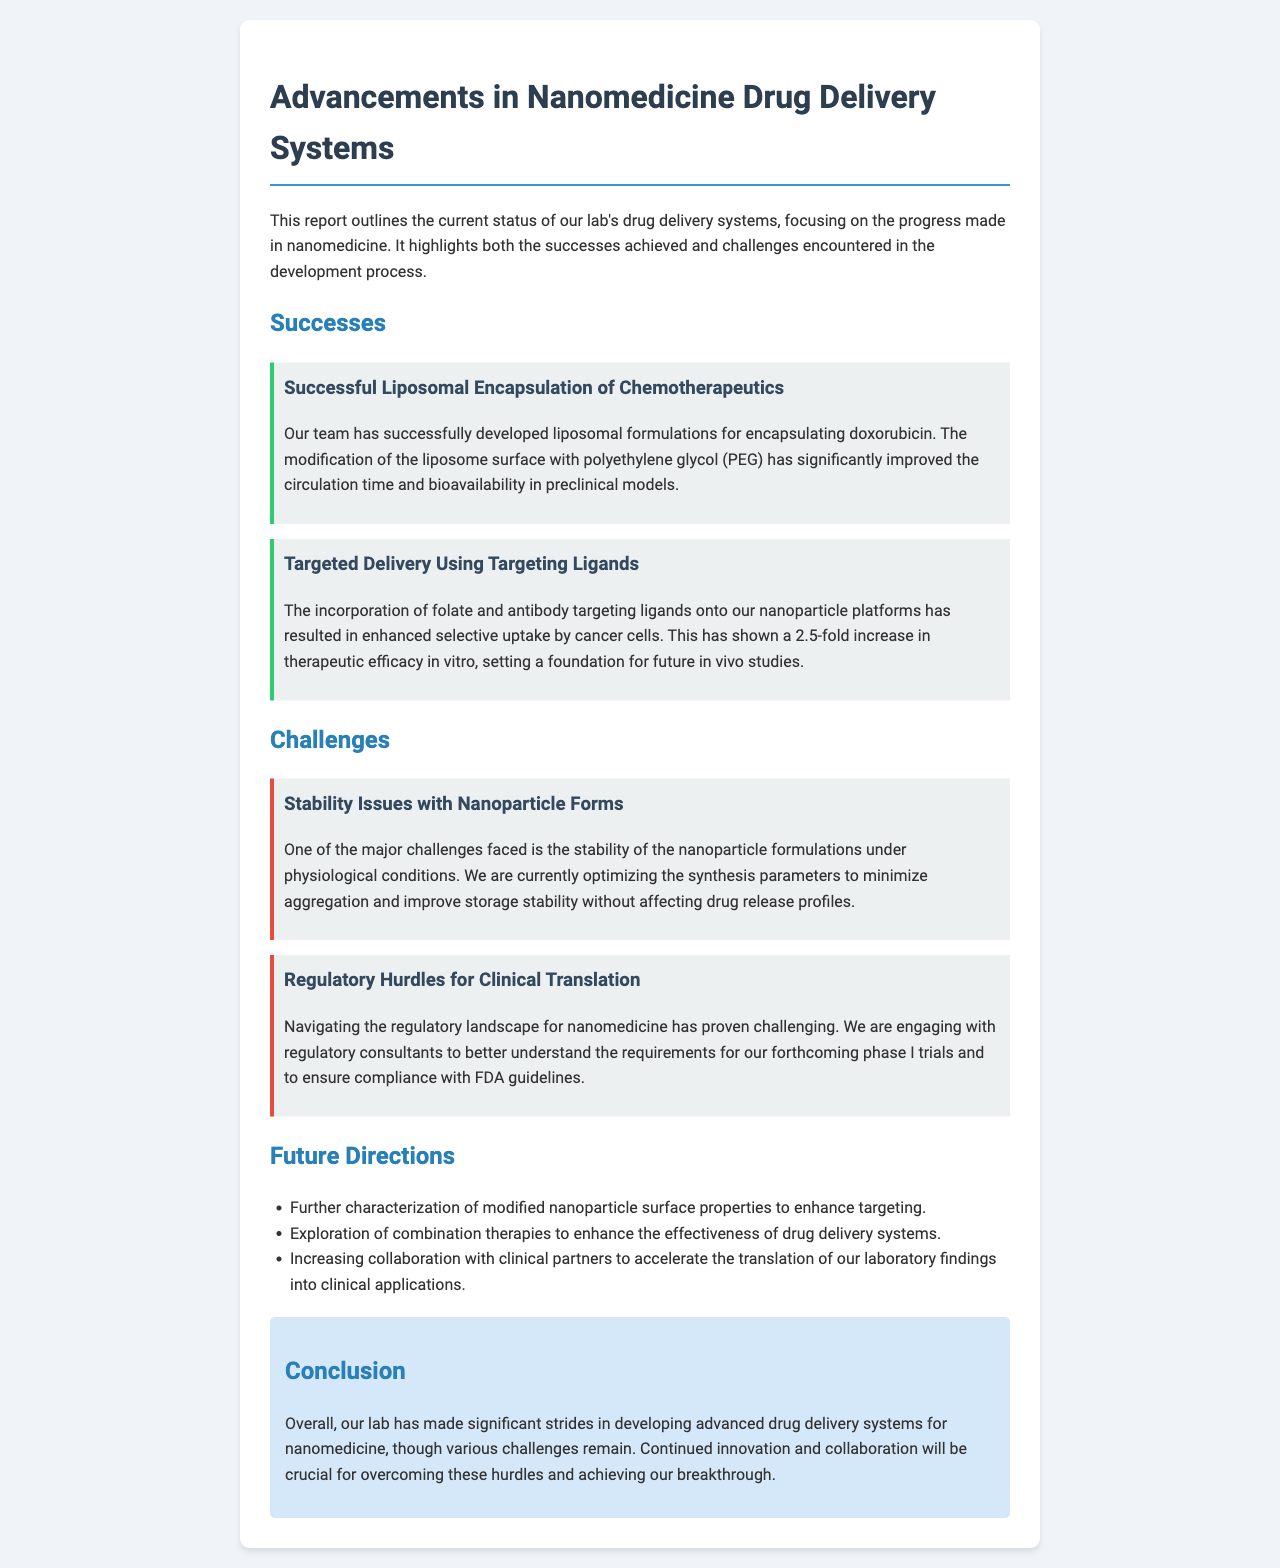What is the main focus of the progress report? The main focus of the report is on the current status of drug delivery systems in nanomedicine, highlighting successes and challenges.
Answer: Drug delivery systems in nanomedicine How much increase in therapeutic efficacy was achieved in vitro? The report mentions a 2.5-fold increase in therapeutic efficacy in vitro due to targeted delivery.
Answer: 2.5-fold What is one of the major challenges faced in the development process? The report states that stability issues with nanoparticle formulations is a major challenge faced.
Answer: Stability issues What modifications improved circulation time and bioavailability? The modification of the liposome surface with polyethylene glycol (PEG) has improved circulation time and bioavailability.
Answer: Polyethylene glycol (PEG) What future direction involves clinical partners? The future direction that involves increasing collaboration with clinical partners aims to accelerate the translation of lab findings into clinical applications.
Answer: Increasing collaboration with clinical partners What type of targeting ligands were used in the nanoparticle platforms? The targeting ligands incorporated onto the nanoparticle platforms included folate and antibody targeting ligands.
Answer: Folate and antibody targeting ligands Which regulatory body's guidelines are mentioned? The guidelines mentioned in the document refer to the FDA (Food and Drug Administration) guidelines.
Answer: FDA What is the report's conclusion about the lab's progress? The conclusion states that significant strides have been made in developing advanced drug delivery systems, though challenges remain.
Answer: Significant strides 